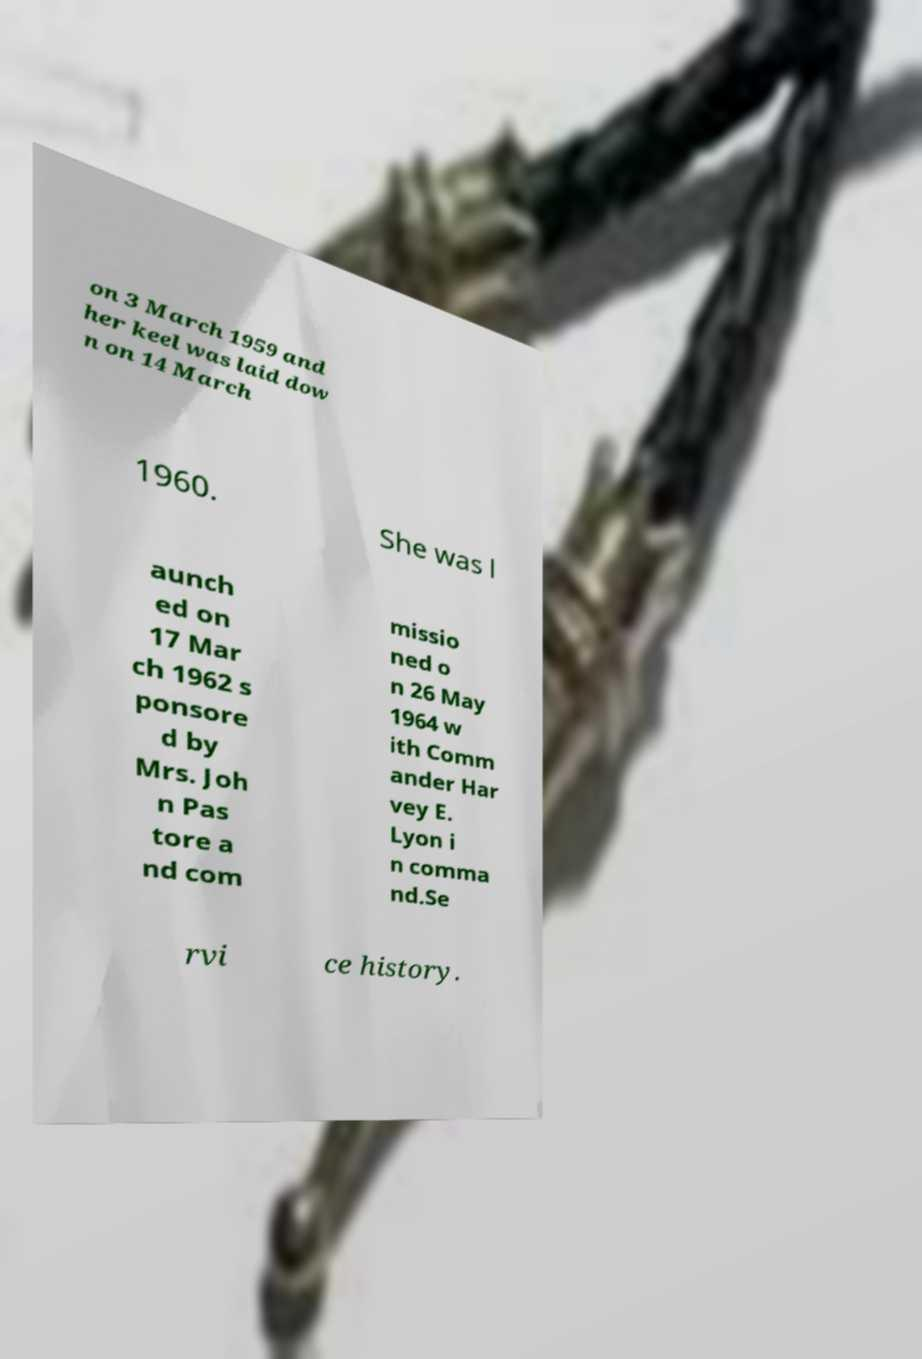Can you read and provide the text displayed in the image?This photo seems to have some interesting text. Can you extract and type it out for me? on 3 March 1959 and her keel was laid dow n on 14 March 1960. She was l aunch ed on 17 Mar ch 1962 s ponsore d by Mrs. Joh n Pas tore a nd com missio ned o n 26 May 1964 w ith Comm ander Har vey E. Lyon i n comma nd.Se rvi ce history. 